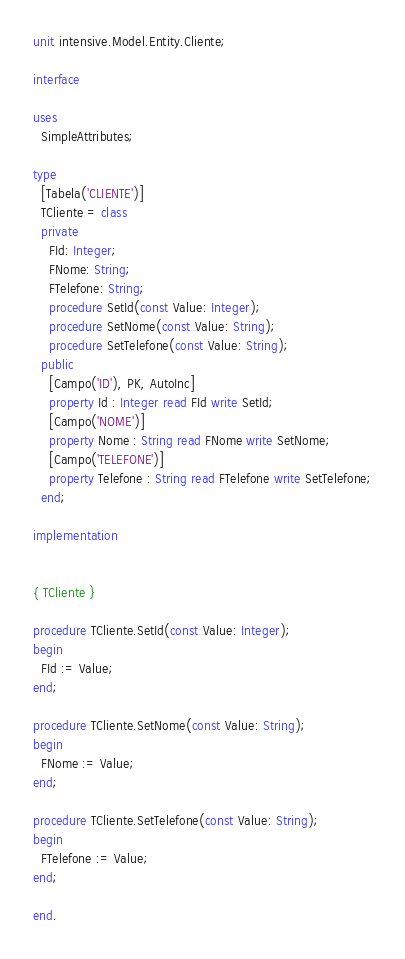<code> <loc_0><loc_0><loc_500><loc_500><_Pascal_>unit intensive.Model.Entity.Cliente;

interface

uses
  SimpleAttributes;

type
  [Tabela('CLIENTE')]
  TCliente = class
  private
    FId: Integer;
    FNome: String;
    FTelefone: String;
    procedure SetId(const Value: Integer);
    procedure SetNome(const Value: String);
    procedure SetTelefone(const Value: String);
  public
    [Campo('ID'), PK, AutoInc]
    property Id : Integer read FId write SetId;
    [Campo('NOME')]
    property Nome : String read FNome write SetNome;
    [Campo('TELEFONE')]
    property Telefone : String read FTelefone write SetTelefone;
  end;

implementation


{ TCliente }

procedure TCliente.SetId(const Value: Integer);
begin
  FId := Value;
end;

procedure TCliente.SetNome(const Value: String);
begin
  FNome := Value;
end;

procedure TCliente.SetTelefone(const Value: String);
begin
  FTelefone := Value;
end;

end.

</code> 